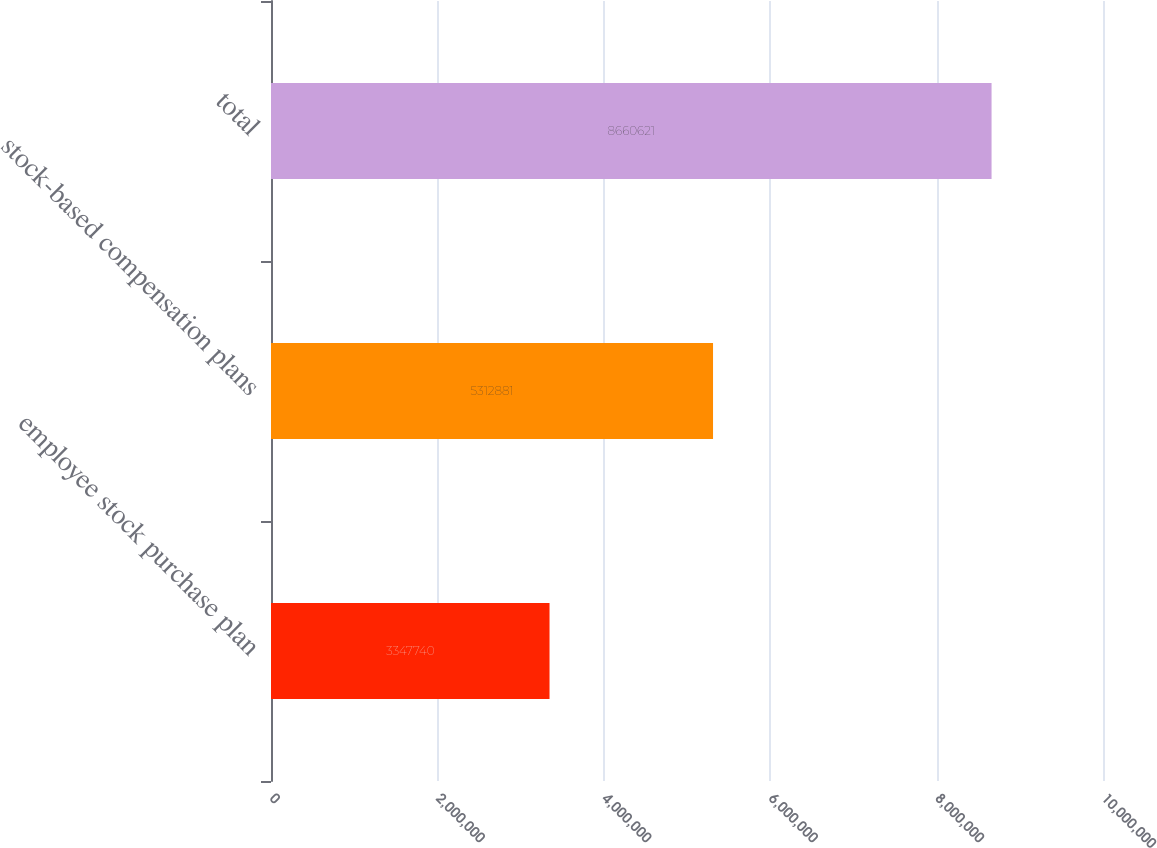Convert chart. <chart><loc_0><loc_0><loc_500><loc_500><bar_chart><fcel>employee stock purchase plan<fcel>stock-based compensation plans<fcel>total<nl><fcel>3.34774e+06<fcel>5.31288e+06<fcel>8.66062e+06<nl></chart> 